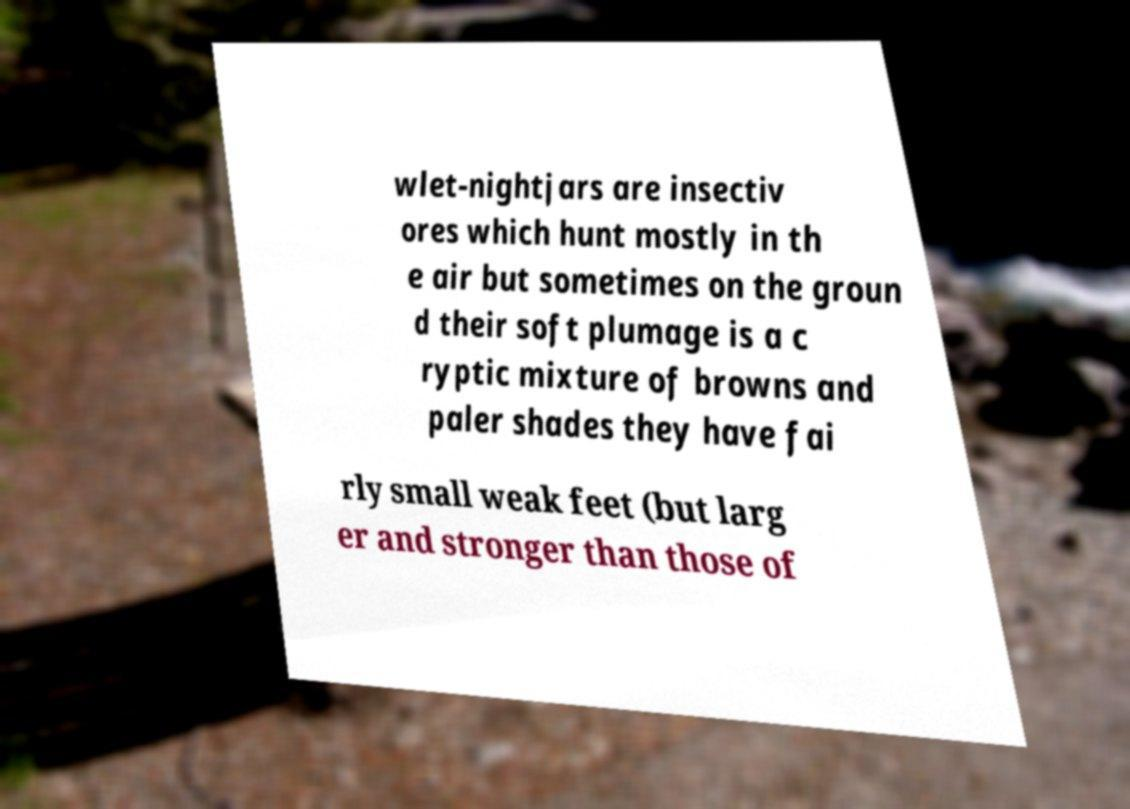There's text embedded in this image that I need extracted. Can you transcribe it verbatim? wlet-nightjars are insectiv ores which hunt mostly in th e air but sometimes on the groun d their soft plumage is a c ryptic mixture of browns and paler shades they have fai rly small weak feet (but larg er and stronger than those of 